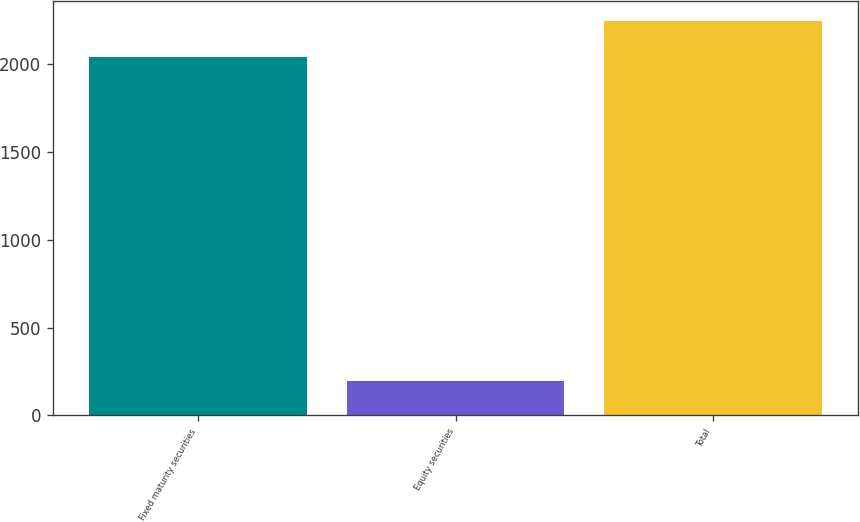<chart> <loc_0><loc_0><loc_500><loc_500><bar_chart><fcel>Fixed maturity securities<fcel>Equity securities<fcel>Total<nl><fcel>2042<fcel>199<fcel>2246.2<nl></chart> 